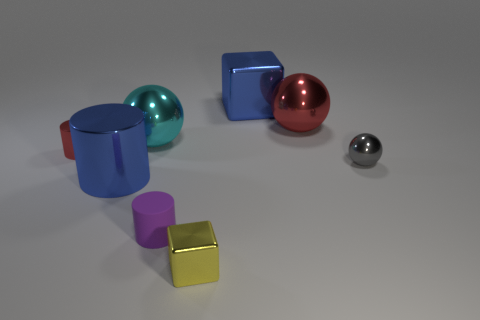What is the size of the cylinder that is to the left of the purple matte cylinder and in front of the small red shiny cylinder?
Your response must be concise. Large. What number of other things are the same shape as the tiny yellow shiny object?
Your answer should be very brief. 1. How many other objects are the same material as the tiny yellow thing?
Offer a terse response. 6. There is a blue metallic object that is the same shape as the yellow metallic thing; what size is it?
Ensure brevity in your answer.  Large. Does the big shiny cylinder have the same color as the big block?
Give a very brief answer. Yes. What is the color of the metal ball that is on the right side of the small yellow shiny object and behind the tiny red cylinder?
Provide a short and direct response. Red. How many things are tiny things behind the rubber object or big brown shiny objects?
Make the answer very short. 2. There is a tiny thing that is the same shape as the big red shiny object; what color is it?
Keep it short and to the point. Gray. Do the yellow metallic thing and the blue metal thing right of the large cylinder have the same shape?
Your response must be concise. Yes. What number of things are shiny things that are in front of the cyan metal sphere or big objects that are to the left of the purple rubber cylinder?
Provide a short and direct response. 5. 